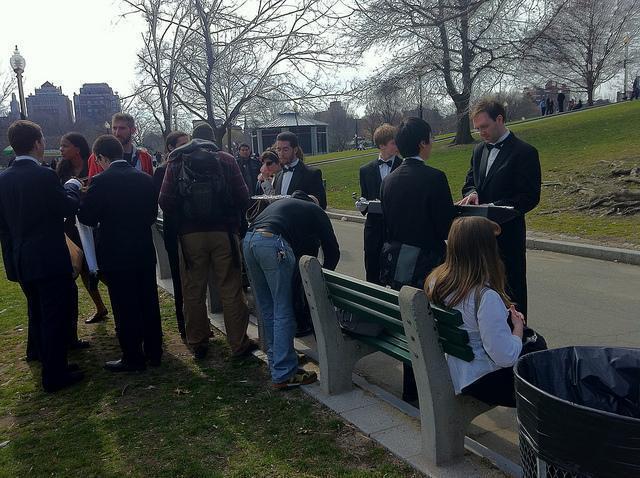What does the man farthest to the right have on his neck?
Choose the right answer from the provided options to respond to the question.
Options: Scarf, hands, goggles, bowtie. Bowtie. 